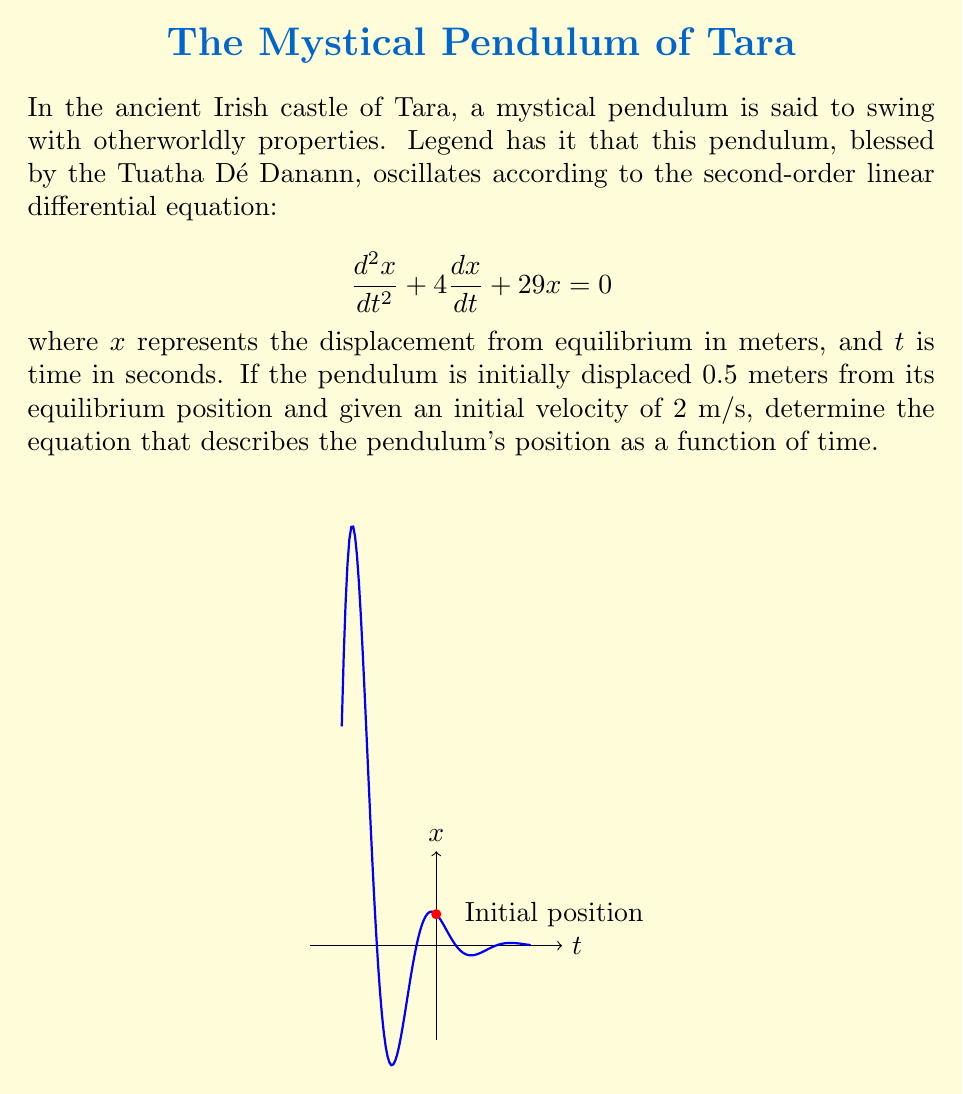What is the answer to this math problem? Let's solve this step-by-step:

1) The characteristic equation for this second-order linear differential equation is:
   $$r^2 + 4r + 29 = 0$$

2) Solving this quadratic equation:
   $$r = \frac{-4 \pm \sqrt{4^2 - 4(1)(29)}}{2(1)} = \frac{-4 \pm \sqrt{-100}}{2} = -2 \pm 5i$$

3) The general solution is therefore:
   $$x(t) = e^{-2t}(A\cos(5t) + B\sin(5t))$$
   where $A$ and $B$ are constants to be determined from the initial conditions.

4) Given initial conditions:
   At $t=0$, $x(0) = 0.5$ and $x'(0) = 2$

5) Using $x(0) = 0.5$:
   $$0.5 = e^{-2(0)}(A\cos(5(0)) + B\sin(5(0))) = A$$

6) For $x'(0) = 2$, we first differentiate $x(t)$:
   $$x'(t) = e^{-2t}(-2A\cos(5t) - 2B\sin(5t) + 5A\sin(5t) - 5B\cos(5t))$$

   Then evaluate at $t=0$:
   $$2 = -2A + 5B$$
   $$2 = -2(0.5) + 5B$$
   $$3 = 5B$$
   $$B = 0.6$$

7) Therefore, the solution is:
   $$x(t) = e^{-2t}(0.5\cos(5t) + 0.6\sin(5t))$$
Answer: $x(t) = e^{-2t}(0.5\cos(5t) + 0.6\sin(5t))$ 